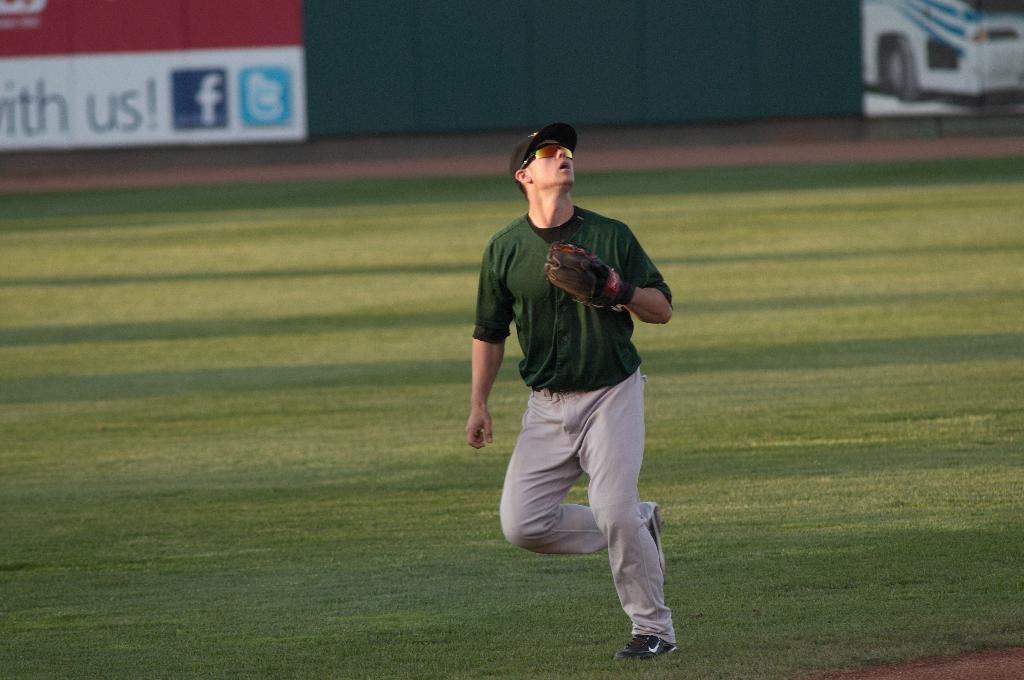<image>
Provide a brief description of the given image. A baseball player is looking up toward the ball in the outfield by a sign that says with us and has a Facebook and Twitter logo. 